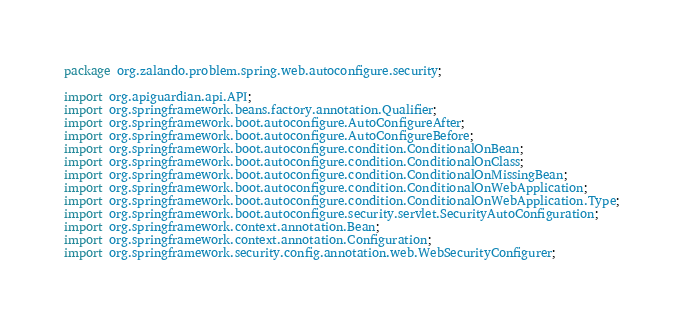<code> <loc_0><loc_0><loc_500><loc_500><_Java_>package org.zalando.problem.spring.web.autoconfigure.security;

import org.apiguardian.api.API;
import org.springframework.beans.factory.annotation.Qualifier;
import org.springframework.boot.autoconfigure.AutoConfigureAfter;
import org.springframework.boot.autoconfigure.AutoConfigureBefore;
import org.springframework.boot.autoconfigure.condition.ConditionalOnBean;
import org.springframework.boot.autoconfigure.condition.ConditionalOnClass;
import org.springframework.boot.autoconfigure.condition.ConditionalOnMissingBean;
import org.springframework.boot.autoconfigure.condition.ConditionalOnWebApplication;
import org.springframework.boot.autoconfigure.condition.ConditionalOnWebApplication.Type;
import org.springframework.boot.autoconfigure.security.servlet.SecurityAutoConfiguration;
import org.springframework.context.annotation.Bean;
import org.springframework.context.annotation.Configuration;
import org.springframework.security.config.annotation.web.WebSecurityConfigurer;</code> 